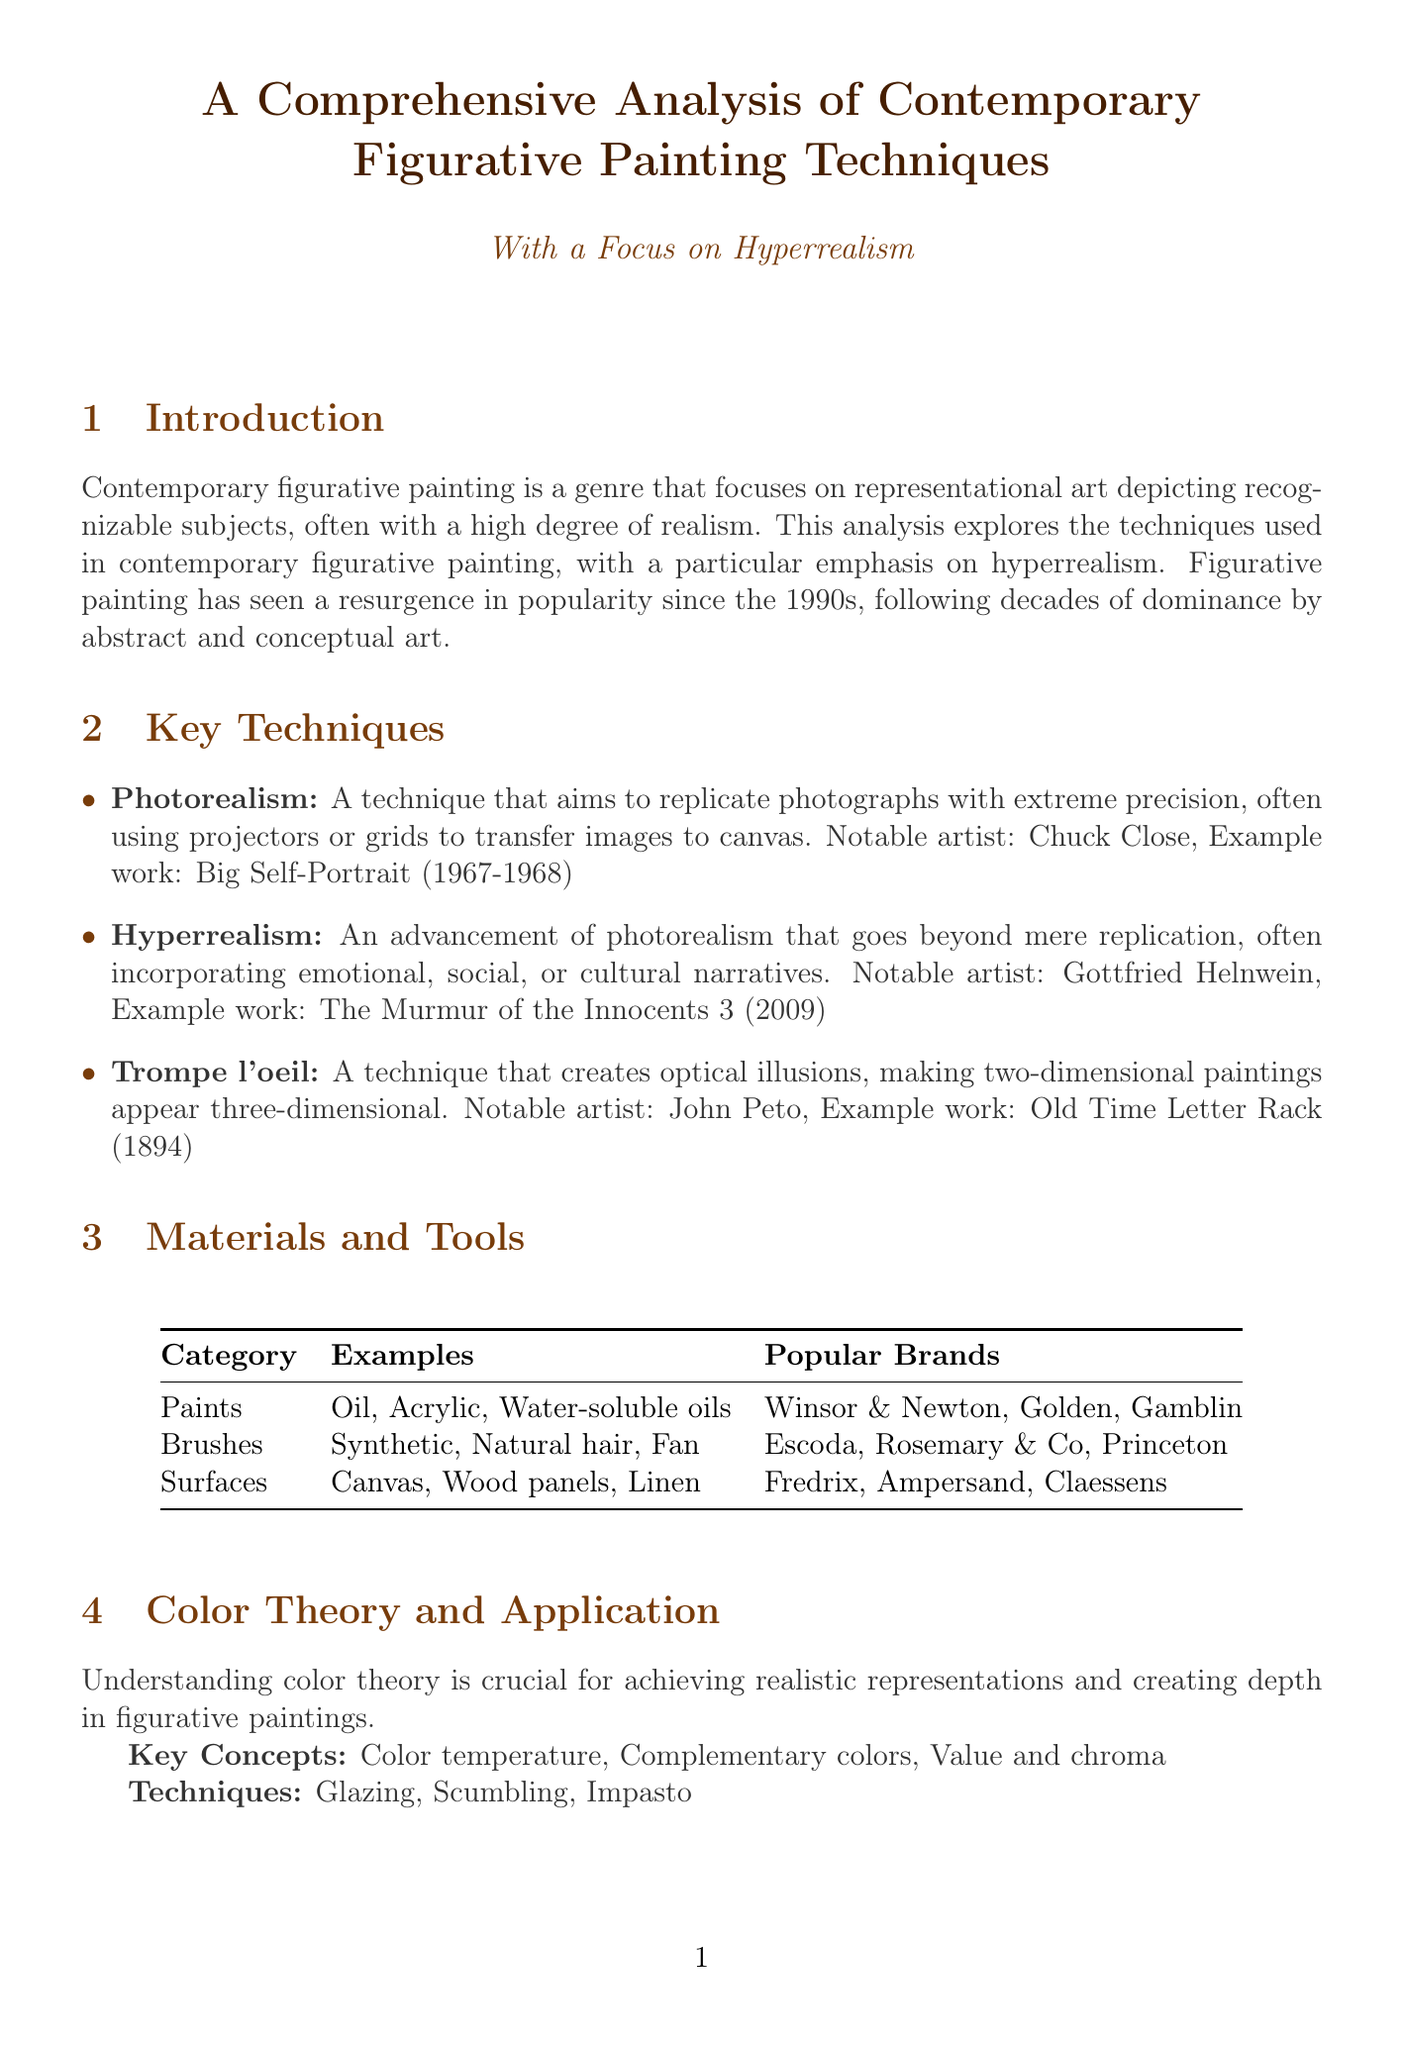What is hyperrealism? Hyperrealism is described in the document as an advancement of photorealism that goes beyond mere replication, often incorporating emotional, social, or cultural narratives.
Answer: An advancement of photorealism Who is a notable artist associated with photorealism? The document provides the name Chuck Close as a notable artist associated with photorealism.
Answer: Chuck Close What was the price of Lucian Freud's notable sale? The document specifies that Lucian Freud's "Benefits Supervisor Sleeping" sold for $33.6 million in 2008.
Answer: $33.6 million What technique creates optical illusions? The document mentions trompe l'oeil as the technique that creates optical illusions, making two-dimensional paintings appear three-dimensional.
Answer: Trompe l'oeil Which common theme is not listed in subject matter? The document lists common themes but does not mention landscapes or animals. The common themes include portraits, still life, urban landscapes, and social commentary.
Answer: Animals 